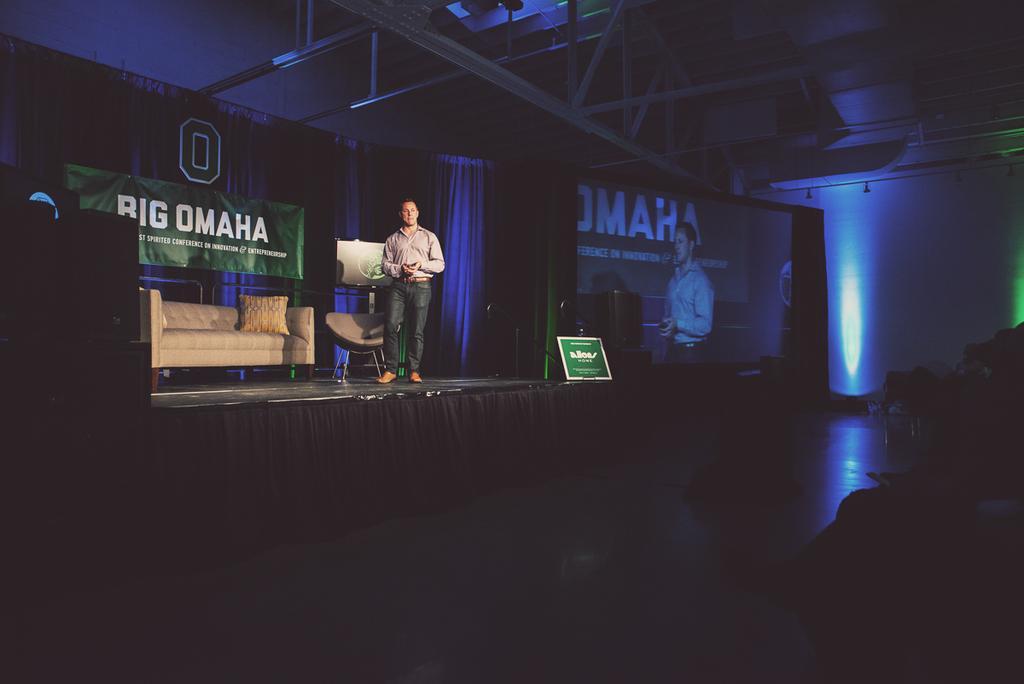Can you describe this image briefly? In front of the image there are people sitting. There is a person standing on the stage. Behind him there is a chair. There is a sofa. On top of it there is a pillow. There are curtains. There is a banner with some text on it. There is a TV. On the right side of the image there is a board. There is a screen. On top of the image there is a roof supported by metal rods. 